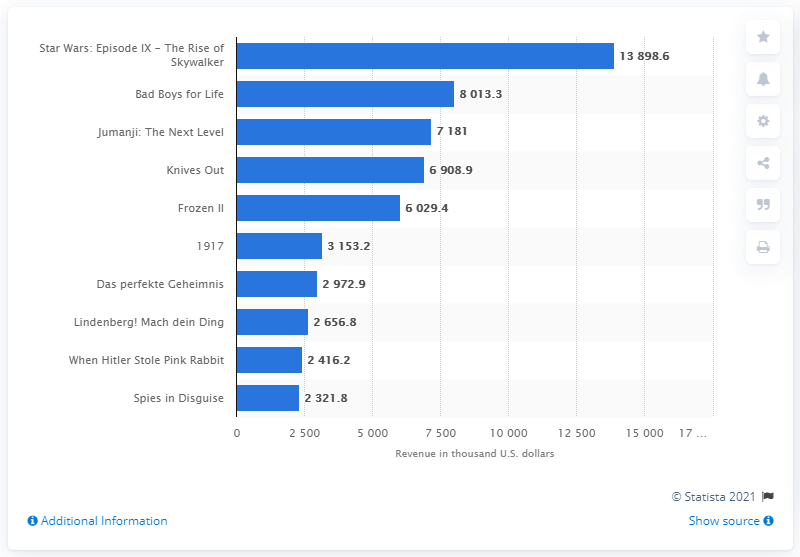Mention a couple of crucial points in this snapshot. In January 2020, the highest grossing film in Germany was "Star Wars: Episode IX - The Rise of Skywalker," which earned a significant amount of revenue. 